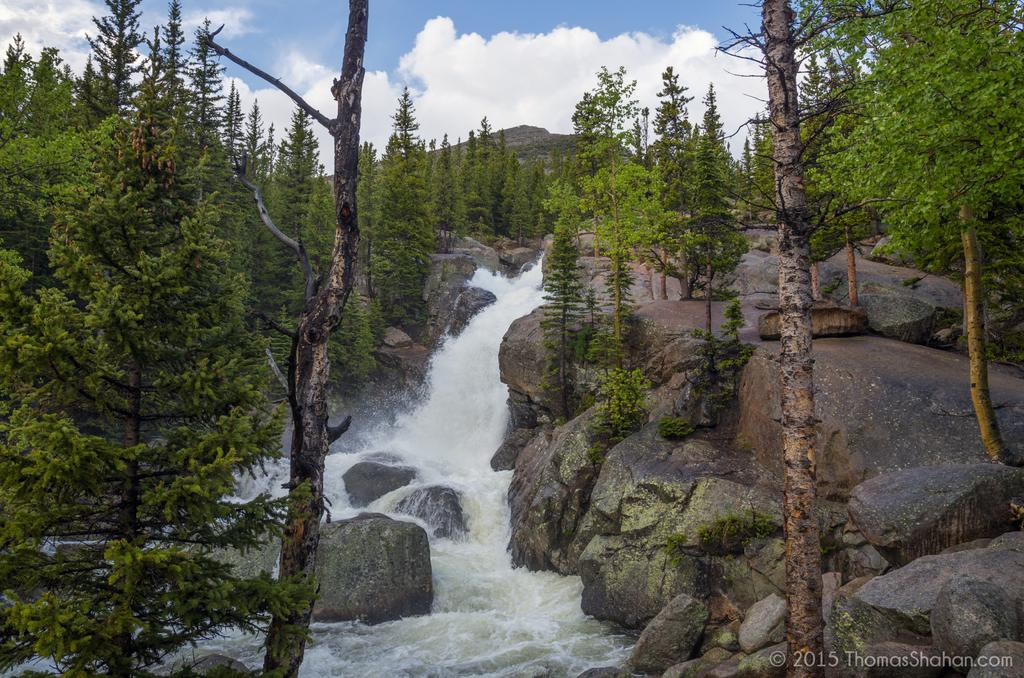What type of geographical feature is present in the image? There are rocky mountains in the image. What can be seen on the mountains? There are trees on the mountains. What natural feature is located in the center of the image? There is a waterfall in the center of the image. What is visible at the top of the image? The sky is visible at the top of the image. Can you tell me how many knives are used to create the waterfall in the image? There are no knives involved in the creation of the waterfall in the image; it is a natural feature formed by the flow of water. 